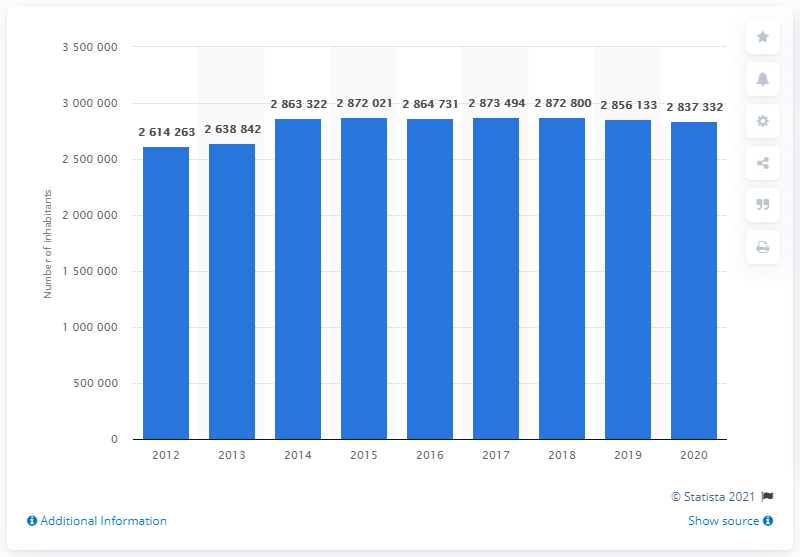What does this bar graph represent? The bar graph in the image illustrates the population statistics of Rome from the year 2012 through 2020. Each bar corresponds to the number of inhabitants for each respective year. Can you describe the trend in the population data over these years? Certainly, the population of Rome shows a fluctuating trend over the years. Starting with 2,614,263 people in 2012, there's a general increase with slight variations, peaking at 2,872,800 in 2017, followed by a gradual decline through to 2020. 